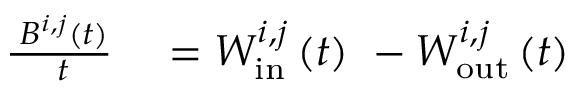Convert formula to latex. <formula><loc_0><loc_0><loc_500><loc_500>\begin{array} { r l } { \frac { \partial B ^ { i , j } ( t ) } { \partial t } } & = W _ { i n } ^ { i , j } \left ( t \right ) \ - W _ { o u t } ^ { i , j } \left ( t \right ) } \end{array}</formula> 